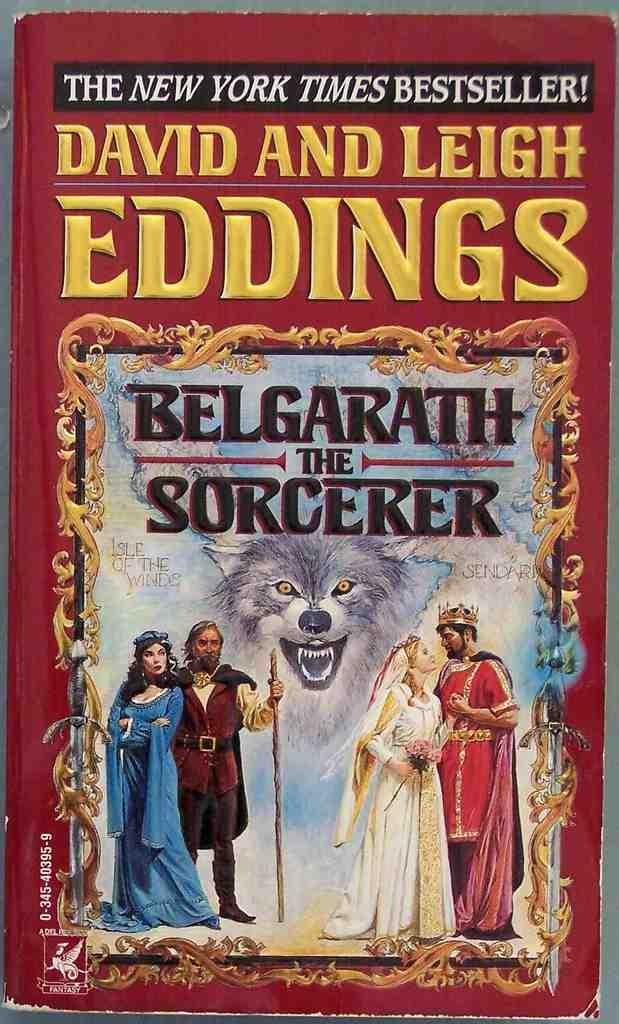<image>
Offer a succinct explanation of the picture presented. Paperback NEW YORK TIMES BEST SELLER of Belgarath the Sorcerer by David and Leigh Eddings 